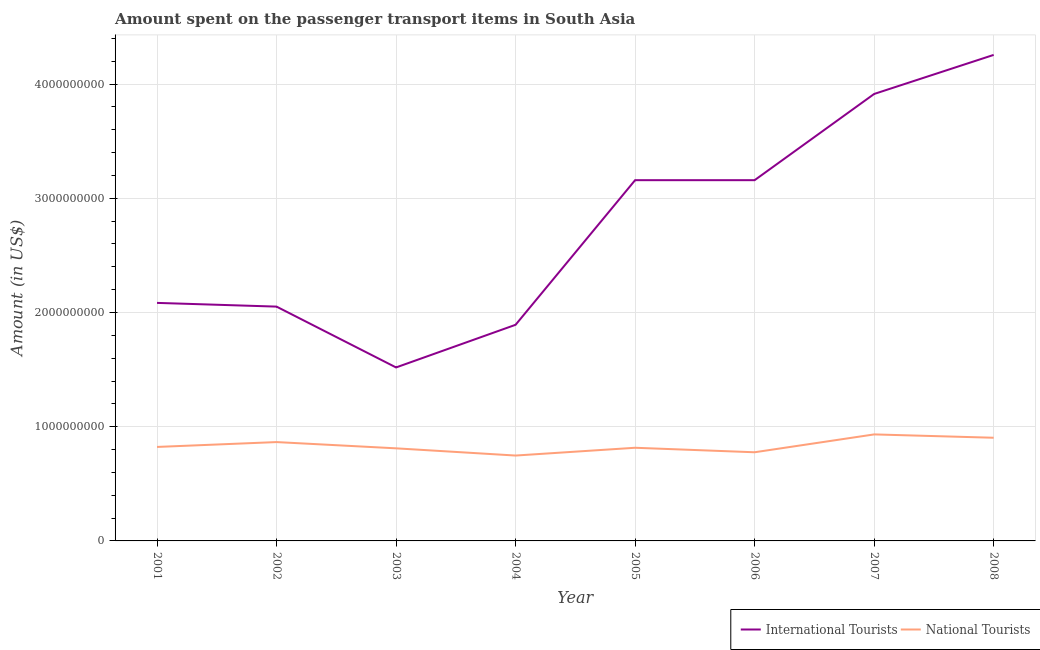Does the line corresponding to amount spent on transport items of international tourists intersect with the line corresponding to amount spent on transport items of national tourists?
Offer a terse response. No. What is the amount spent on transport items of national tourists in 2002?
Offer a very short reply. 8.66e+08. Across all years, what is the maximum amount spent on transport items of international tourists?
Make the answer very short. 4.26e+09. Across all years, what is the minimum amount spent on transport items of national tourists?
Your answer should be very brief. 7.48e+08. In which year was the amount spent on transport items of international tourists maximum?
Your answer should be very brief. 2008. What is the total amount spent on transport items of national tourists in the graph?
Your answer should be very brief. 6.68e+09. What is the difference between the amount spent on transport items of national tourists in 2004 and that in 2005?
Your answer should be compact. -6.81e+07. What is the difference between the amount spent on transport items of international tourists in 2004 and the amount spent on transport items of national tourists in 2002?
Ensure brevity in your answer.  1.03e+09. What is the average amount spent on transport items of international tourists per year?
Keep it short and to the point. 2.75e+09. In the year 2002, what is the difference between the amount spent on transport items of international tourists and amount spent on transport items of national tourists?
Offer a terse response. 1.19e+09. What is the ratio of the amount spent on transport items of international tourists in 2002 to that in 2005?
Your response must be concise. 0.65. Is the difference between the amount spent on transport items of national tourists in 2001 and 2008 greater than the difference between the amount spent on transport items of international tourists in 2001 and 2008?
Give a very brief answer. Yes. What is the difference between the highest and the second highest amount spent on transport items of national tourists?
Keep it short and to the point. 2.92e+07. What is the difference between the highest and the lowest amount spent on transport items of international tourists?
Keep it short and to the point. 2.74e+09. Is the sum of the amount spent on transport items of national tourists in 2002 and 2005 greater than the maximum amount spent on transport items of international tourists across all years?
Keep it short and to the point. No. Does the amount spent on transport items of international tourists monotonically increase over the years?
Offer a terse response. No. Is the amount spent on transport items of national tourists strictly less than the amount spent on transport items of international tourists over the years?
Provide a short and direct response. Yes. How many lines are there?
Offer a very short reply. 2. How many years are there in the graph?
Give a very brief answer. 8. Where does the legend appear in the graph?
Provide a succinct answer. Bottom right. What is the title of the graph?
Keep it short and to the point. Amount spent on the passenger transport items in South Asia. Does "Under-5(female)" appear as one of the legend labels in the graph?
Give a very brief answer. No. What is the label or title of the Y-axis?
Offer a terse response. Amount (in US$). What is the Amount (in US$) of International Tourists in 2001?
Provide a short and direct response. 2.08e+09. What is the Amount (in US$) in National Tourists in 2001?
Offer a very short reply. 8.23e+08. What is the Amount (in US$) in International Tourists in 2002?
Offer a terse response. 2.05e+09. What is the Amount (in US$) in National Tourists in 2002?
Give a very brief answer. 8.66e+08. What is the Amount (in US$) in International Tourists in 2003?
Provide a succinct answer. 1.52e+09. What is the Amount (in US$) in National Tourists in 2003?
Offer a terse response. 8.11e+08. What is the Amount (in US$) in International Tourists in 2004?
Ensure brevity in your answer.  1.89e+09. What is the Amount (in US$) in National Tourists in 2004?
Offer a very short reply. 7.48e+08. What is the Amount (in US$) in International Tourists in 2005?
Provide a short and direct response. 3.16e+09. What is the Amount (in US$) in National Tourists in 2005?
Offer a very short reply. 8.16e+08. What is the Amount (in US$) of International Tourists in 2006?
Provide a short and direct response. 3.16e+09. What is the Amount (in US$) of National Tourists in 2006?
Offer a very short reply. 7.76e+08. What is the Amount (in US$) of International Tourists in 2007?
Give a very brief answer. 3.91e+09. What is the Amount (in US$) of National Tourists in 2007?
Your answer should be very brief. 9.33e+08. What is the Amount (in US$) of International Tourists in 2008?
Offer a very short reply. 4.26e+09. What is the Amount (in US$) in National Tourists in 2008?
Keep it short and to the point. 9.03e+08. Across all years, what is the maximum Amount (in US$) in International Tourists?
Provide a succinct answer. 4.26e+09. Across all years, what is the maximum Amount (in US$) in National Tourists?
Your answer should be very brief. 9.33e+08. Across all years, what is the minimum Amount (in US$) of International Tourists?
Your response must be concise. 1.52e+09. Across all years, what is the minimum Amount (in US$) in National Tourists?
Provide a short and direct response. 7.48e+08. What is the total Amount (in US$) of International Tourists in the graph?
Give a very brief answer. 2.20e+1. What is the total Amount (in US$) of National Tourists in the graph?
Give a very brief answer. 6.68e+09. What is the difference between the Amount (in US$) in International Tourists in 2001 and that in 2002?
Your answer should be very brief. 3.25e+07. What is the difference between the Amount (in US$) of National Tourists in 2001 and that in 2002?
Your answer should be very brief. -4.25e+07. What is the difference between the Amount (in US$) in International Tourists in 2001 and that in 2003?
Offer a terse response. 5.65e+08. What is the difference between the Amount (in US$) of National Tourists in 2001 and that in 2003?
Provide a short and direct response. 1.22e+07. What is the difference between the Amount (in US$) in International Tourists in 2001 and that in 2004?
Offer a terse response. 1.92e+08. What is the difference between the Amount (in US$) of National Tourists in 2001 and that in 2004?
Offer a very short reply. 7.54e+07. What is the difference between the Amount (in US$) in International Tourists in 2001 and that in 2005?
Your answer should be very brief. -1.07e+09. What is the difference between the Amount (in US$) in National Tourists in 2001 and that in 2005?
Ensure brevity in your answer.  7.29e+06. What is the difference between the Amount (in US$) of International Tourists in 2001 and that in 2006?
Provide a short and direct response. -1.07e+09. What is the difference between the Amount (in US$) of National Tourists in 2001 and that in 2006?
Offer a terse response. 4.66e+07. What is the difference between the Amount (in US$) in International Tourists in 2001 and that in 2007?
Your response must be concise. -1.83e+09. What is the difference between the Amount (in US$) in National Tourists in 2001 and that in 2007?
Offer a terse response. -1.10e+08. What is the difference between the Amount (in US$) in International Tourists in 2001 and that in 2008?
Your answer should be compact. -2.17e+09. What is the difference between the Amount (in US$) in National Tourists in 2001 and that in 2008?
Make the answer very short. -8.05e+07. What is the difference between the Amount (in US$) of International Tourists in 2002 and that in 2003?
Make the answer very short. 5.33e+08. What is the difference between the Amount (in US$) in National Tourists in 2002 and that in 2003?
Give a very brief answer. 5.47e+07. What is the difference between the Amount (in US$) in International Tourists in 2002 and that in 2004?
Your answer should be compact. 1.59e+08. What is the difference between the Amount (in US$) in National Tourists in 2002 and that in 2004?
Offer a very short reply. 1.18e+08. What is the difference between the Amount (in US$) in International Tourists in 2002 and that in 2005?
Your answer should be compact. -1.11e+09. What is the difference between the Amount (in US$) of National Tourists in 2002 and that in 2005?
Give a very brief answer. 4.98e+07. What is the difference between the Amount (in US$) in International Tourists in 2002 and that in 2006?
Give a very brief answer. -1.11e+09. What is the difference between the Amount (in US$) of National Tourists in 2002 and that in 2006?
Provide a succinct answer. 8.92e+07. What is the difference between the Amount (in US$) in International Tourists in 2002 and that in 2007?
Offer a terse response. -1.86e+09. What is the difference between the Amount (in US$) of National Tourists in 2002 and that in 2007?
Offer a very short reply. -6.71e+07. What is the difference between the Amount (in US$) in International Tourists in 2002 and that in 2008?
Provide a succinct answer. -2.20e+09. What is the difference between the Amount (in US$) of National Tourists in 2002 and that in 2008?
Ensure brevity in your answer.  -3.79e+07. What is the difference between the Amount (in US$) in International Tourists in 2003 and that in 2004?
Offer a terse response. -3.73e+08. What is the difference between the Amount (in US$) of National Tourists in 2003 and that in 2004?
Provide a short and direct response. 6.32e+07. What is the difference between the Amount (in US$) in International Tourists in 2003 and that in 2005?
Provide a short and direct response. -1.64e+09. What is the difference between the Amount (in US$) of National Tourists in 2003 and that in 2005?
Offer a very short reply. -4.86e+06. What is the difference between the Amount (in US$) in International Tourists in 2003 and that in 2006?
Your answer should be very brief. -1.64e+09. What is the difference between the Amount (in US$) of National Tourists in 2003 and that in 2006?
Your response must be concise. 3.45e+07. What is the difference between the Amount (in US$) of International Tourists in 2003 and that in 2007?
Your answer should be very brief. -2.39e+09. What is the difference between the Amount (in US$) of National Tourists in 2003 and that in 2007?
Provide a succinct answer. -1.22e+08. What is the difference between the Amount (in US$) in International Tourists in 2003 and that in 2008?
Your response must be concise. -2.74e+09. What is the difference between the Amount (in US$) of National Tourists in 2003 and that in 2008?
Offer a very short reply. -9.26e+07. What is the difference between the Amount (in US$) of International Tourists in 2004 and that in 2005?
Your response must be concise. -1.27e+09. What is the difference between the Amount (in US$) of National Tourists in 2004 and that in 2005?
Keep it short and to the point. -6.81e+07. What is the difference between the Amount (in US$) of International Tourists in 2004 and that in 2006?
Ensure brevity in your answer.  -1.27e+09. What is the difference between the Amount (in US$) in National Tourists in 2004 and that in 2006?
Keep it short and to the point. -2.88e+07. What is the difference between the Amount (in US$) of International Tourists in 2004 and that in 2007?
Provide a short and direct response. -2.02e+09. What is the difference between the Amount (in US$) in National Tourists in 2004 and that in 2007?
Provide a short and direct response. -1.85e+08. What is the difference between the Amount (in US$) of International Tourists in 2004 and that in 2008?
Your answer should be compact. -2.36e+09. What is the difference between the Amount (in US$) of National Tourists in 2004 and that in 2008?
Keep it short and to the point. -1.56e+08. What is the difference between the Amount (in US$) in International Tourists in 2005 and that in 2006?
Your response must be concise. 0. What is the difference between the Amount (in US$) in National Tourists in 2005 and that in 2006?
Make the answer very short. 3.93e+07. What is the difference between the Amount (in US$) in International Tourists in 2005 and that in 2007?
Provide a short and direct response. -7.55e+08. What is the difference between the Amount (in US$) in National Tourists in 2005 and that in 2007?
Your answer should be very brief. -1.17e+08. What is the difference between the Amount (in US$) of International Tourists in 2005 and that in 2008?
Provide a succinct answer. -1.10e+09. What is the difference between the Amount (in US$) in National Tourists in 2005 and that in 2008?
Keep it short and to the point. -8.78e+07. What is the difference between the Amount (in US$) in International Tourists in 2006 and that in 2007?
Provide a succinct answer. -7.55e+08. What is the difference between the Amount (in US$) of National Tourists in 2006 and that in 2007?
Your response must be concise. -1.56e+08. What is the difference between the Amount (in US$) in International Tourists in 2006 and that in 2008?
Provide a short and direct response. -1.10e+09. What is the difference between the Amount (in US$) in National Tourists in 2006 and that in 2008?
Your response must be concise. -1.27e+08. What is the difference between the Amount (in US$) of International Tourists in 2007 and that in 2008?
Your answer should be very brief. -3.42e+08. What is the difference between the Amount (in US$) of National Tourists in 2007 and that in 2008?
Provide a short and direct response. 2.92e+07. What is the difference between the Amount (in US$) of International Tourists in 2001 and the Amount (in US$) of National Tourists in 2002?
Make the answer very short. 1.22e+09. What is the difference between the Amount (in US$) of International Tourists in 2001 and the Amount (in US$) of National Tourists in 2003?
Offer a very short reply. 1.27e+09. What is the difference between the Amount (in US$) in International Tourists in 2001 and the Amount (in US$) in National Tourists in 2004?
Your answer should be very brief. 1.34e+09. What is the difference between the Amount (in US$) in International Tourists in 2001 and the Amount (in US$) in National Tourists in 2005?
Give a very brief answer. 1.27e+09. What is the difference between the Amount (in US$) of International Tourists in 2001 and the Amount (in US$) of National Tourists in 2006?
Offer a terse response. 1.31e+09. What is the difference between the Amount (in US$) in International Tourists in 2001 and the Amount (in US$) in National Tourists in 2007?
Keep it short and to the point. 1.15e+09. What is the difference between the Amount (in US$) of International Tourists in 2001 and the Amount (in US$) of National Tourists in 2008?
Make the answer very short. 1.18e+09. What is the difference between the Amount (in US$) in International Tourists in 2002 and the Amount (in US$) in National Tourists in 2003?
Give a very brief answer. 1.24e+09. What is the difference between the Amount (in US$) of International Tourists in 2002 and the Amount (in US$) of National Tourists in 2004?
Make the answer very short. 1.30e+09. What is the difference between the Amount (in US$) of International Tourists in 2002 and the Amount (in US$) of National Tourists in 2005?
Give a very brief answer. 1.24e+09. What is the difference between the Amount (in US$) of International Tourists in 2002 and the Amount (in US$) of National Tourists in 2006?
Make the answer very short. 1.28e+09. What is the difference between the Amount (in US$) of International Tourists in 2002 and the Amount (in US$) of National Tourists in 2007?
Keep it short and to the point. 1.12e+09. What is the difference between the Amount (in US$) of International Tourists in 2002 and the Amount (in US$) of National Tourists in 2008?
Give a very brief answer. 1.15e+09. What is the difference between the Amount (in US$) of International Tourists in 2003 and the Amount (in US$) of National Tourists in 2004?
Your answer should be compact. 7.71e+08. What is the difference between the Amount (in US$) in International Tourists in 2003 and the Amount (in US$) in National Tourists in 2005?
Provide a short and direct response. 7.03e+08. What is the difference between the Amount (in US$) of International Tourists in 2003 and the Amount (in US$) of National Tourists in 2006?
Provide a succinct answer. 7.43e+08. What is the difference between the Amount (in US$) of International Tourists in 2003 and the Amount (in US$) of National Tourists in 2007?
Give a very brief answer. 5.86e+08. What is the difference between the Amount (in US$) of International Tourists in 2003 and the Amount (in US$) of National Tourists in 2008?
Make the answer very short. 6.16e+08. What is the difference between the Amount (in US$) of International Tourists in 2004 and the Amount (in US$) of National Tourists in 2005?
Your answer should be very brief. 1.08e+09. What is the difference between the Amount (in US$) in International Tourists in 2004 and the Amount (in US$) in National Tourists in 2006?
Give a very brief answer. 1.12e+09. What is the difference between the Amount (in US$) of International Tourists in 2004 and the Amount (in US$) of National Tourists in 2007?
Offer a very short reply. 9.60e+08. What is the difference between the Amount (in US$) of International Tourists in 2004 and the Amount (in US$) of National Tourists in 2008?
Offer a terse response. 9.89e+08. What is the difference between the Amount (in US$) of International Tourists in 2005 and the Amount (in US$) of National Tourists in 2006?
Your answer should be very brief. 2.38e+09. What is the difference between the Amount (in US$) of International Tourists in 2005 and the Amount (in US$) of National Tourists in 2007?
Your answer should be compact. 2.23e+09. What is the difference between the Amount (in US$) of International Tourists in 2005 and the Amount (in US$) of National Tourists in 2008?
Your answer should be very brief. 2.26e+09. What is the difference between the Amount (in US$) in International Tourists in 2006 and the Amount (in US$) in National Tourists in 2007?
Offer a terse response. 2.23e+09. What is the difference between the Amount (in US$) in International Tourists in 2006 and the Amount (in US$) in National Tourists in 2008?
Offer a terse response. 2.26e+09. What is the difference between the Amount (in US$) of International Tourists in 2007 and the Amount (in US$) of National Tourists in 2008?
Offer a very short reply. 3.01e+09. What is the average Amount (in US$) of International Tourists per year?
Provide a succinct answer. 2.75e+09. What is the average Amount (in US$) of National Tourists per year?
Offer a terse response. 8.34e+08. In the year 2001, what is the difference between the Amount (in US$) of International Tourists and Amount (in US$) of National Tourists?
Keep it short and to the point. 1.26e+09. In the year 2002, what is the difference between the Amount (in US$) in International Tourists and Amount (in US$) in National Tourists?
Your answer should be compact. 1.19e+09. In the year 2003, what is the difference between the Amount (in US$) of International Tourists and Amount (in US$) of National Tourists?
Make the answer very short. 7.08e+08. In the year 2004, what is the difference between the Amount (in US$) of International Tourists and Amount (in US$) of National Tourists?
Provide a succinct answer. 1.14e+09. In the year 2005, what is the difference between the Amount (in US$) in International Tourists and Amount (in US$) in National Tourists?
Ensure brevity in your answer.  2.34e+09. In the year 2006, what is the difference between the Amount (in US$) in International Tourists and Amount (in US$) in National Tourists?
Your response must be concise. 2.38e+09. In the year 2007, what is the difference between the Amount (in US$) of International Tourists and Amount (in US$) of National Tourists?
Your answer should be very brief. 2.98e+09. In the year 2008, what is the difference between the Amount (in US$) of International Tourists and Amount (in US$) of National Tourists?
Offer a terse response. 3.35e+09. What is the ratio of the Amount (in US$) of International Tourists in 2001 to that in 2002?
Offer a terse response. 1.02. What is the ratio of the Amount (in US$) of National Tourists in 2001 to that in 2002?
Your answer should be compact. 0.95. What is the ratio of the Amount (in US$) of International Tourists in 2001 to that in 2003?
Ensure brevity in your answer.  1.37. What is the ratio of the Amount (in US$) in National Tourists in 2001 to that in 2003?
Offer a terse response. 1.01. What is the ratio of the Amount (in US$) in International Tourists in 2001 to that in 2004?
Make the answer very short. 1.1. What is the ratio of the Amount (in US$) in National Tourists in 2001 to that in 2004?
Offer a terse response. 1.1. What is the ratio of the Amount (in US$) in International Tourists in 2001 to that in 2005?
Keep it short and to the point. 0.66. What is the ratio of the Amount (in US$) in National Tourists in 2001 to that in 2005?
Ensure brevity in your answer.  1.01. What is the ratio of the Amount (in US$) of International Tourists in 2001 to that in 2006?
Provide a succinct answer. 0.66. What is the ratio of the Amount (in US$) of National Tourists in 2001 to that in 2006?
Ensure brevity in your answer.  1.06. What is the ratio of the Amount (in US$) of International Tourists in 2001 to that in 2007?
Provide a short and direct response. 0.53. What is the ratio of the Amount (in US$) of National Tourists in 2001 to that in 2007?
Your answer should be very brief. 0.88. What is the ratio of the Amount (in US$) of International Tourists in 2001 to that in 2008?
Provide a short and direct response. 0.49. What is the ratio of the Amount (in US$) of National Tourists in 2001 to that in 2008?
Provide a succinct answer. 0.91. What is the ratio of the Amount (in US$) of International Tourists in 2002 to that in 2003?
Your answer should be very brief. 1.35. What is the ratio of the Amount (in US$) in National Tourists in 2002 to that in 2003?
Your answer should be very brief. 1.07. What is the ratio of the Amount (in US$) in International Tourists in 2002 to that in 2004?
Your answer should be compact. 1.08. What is the ratio of the Amount (in US$) of National Tourists in 2002 to that in 2004?
Offer a very short reply. 1.16. What is the ratio of the Amount (in US$) of International Tourists in 2002 to that in 2005?
Provide a short and direct response. 0.65. What is the ratio of the Amount (in US$) of National Tourists in 2002 to that in 2005?
Provide a short and direct response. 1.06. What is the ratio of the Amount (in US$) in International Tourists in 2002 to that in 2006?
Offer a terse response. 0.65. What is the ratio of the Amount (in US$) of National Tourists in 2002 to that in 2006?
Provide a succinct answer. 1.11. What is the ratio of the Amount (in US$) of International Tourists in 2002 to that in 2007?
Your response must be concise. 0.52. What is the ratio of the Amount (in US$) of National Tourists in 2002 to that in 2007?
Your answer should be very brief. 0.93. What is the ratio of the Amount (in US$) in International Tourists in 2002 to that in 2008?
Provide a succinct answer. 0.48. What is the ratio of the Amount (in US$) of National Tourists in 2002 to that in 2008?
Provide a short and direct response. 0.96. What is the ratio of the Amount (in US$) of International Tourists in 2003 to that in 2004?
Offer a terse response. 0.8. What is the ratio of the Amount (in US$) of National Tourists in 2003 to that in 2004?
Your answer should be compact. 1.08. What is the ratio of the Amount (in US$) in International Tourists in 2003 to that in 2005?
Keep it short and to the point. 0.48. What is the ratio of the Amount (in US$) in National Tourists in 2003 to that in 2005?
Your answer should be very brief. 0.99. What is the ratio of the Amount (in US$) of International Tourists in 2003 to that in 2006?
Provide a short and direct response. 0.48. What is the ratio of the Amount (in US$) of National Tourists in 2003 to that in 2006?
Make the answer very short. 1.04. What is the ratio of the Amount (in US$) in International Tourists in 2003 to that in 2007?
Offer a very short reply. 0.39. What is the ratio of the Amount (in US$) of National Tourists in 2003 to that in 2007?
Give a very brief answer. 0.87. What is the ratio of the Amount (in US$) in International Tourists in 2003 to that in 2008?
Your response must be concise. 0.36. What is the ratio of the Amount (in US$) in National Tourists in 2003 to that in 2008?
Offer a terse response. 0.9. What is the ratio of the Amount (in US$) of International Tourists in 2004 to that in 2005?
Offer a terse response. 0.6. What is the ratio of the Amount (in US$) of National Tourists in 2004 to that in 2005?
Your answer should be very brief. 0.92. What is the ratio of the Amount (in US$) in International Tourists in 2004 to that in 2006?
Keep it short and to the point. 0.6. What is the ratio of the Amount (in US$) of National Tourists in 2004 to that in 2006?
Your answer should be compact. 0.96. What is the ratio of the Amount (in US$) of International Tourists in 2004 to that in 2007?
Your answer should be compact. 0.48. What is the ratio of the Amount (in US$) of National Tourists in 2004 to that in 2007?
Offer a terse response. 0.8. What is the ratio of the Amount (in US$) of International Tourists in 2004 to that in 2008?
Your answer should be very brief. 0.44. What is the ratio of the Amount (in US$) in National Tourists in 2004 to that in 2008?
Provide a succinct answer. 0.83. What is the ratio of the Amount (in US$) of National Tourists in 2005 to that in 2006?
Offer a very short reply. 1.05. What is the ratio of the Amount (in US$) in International Tourists in 2005 to that in 2007?
Offer a terse response. 0.81. What is the ratio of the Amount (in US$) of National Tourists in 2005 to that in 2007?
Offer a terse response. 0.87. What is the ratio of the Amount (in US$) of International Tourists in 2005 to that in 2008?
Your response must be concise. 0.74. What is the ratio of the Amount (in US$) of National Tourists in 2005 to that in 2008?
Provide a short and direct response. 0.9. What is the ratio of the Amount (in US$) of International Tourists in 2006 to that in 2007?
Provide a short and direct response. 0.81. What is the ratio of the Amount (in US$) of National Tourists in 2006 to that in 2007?
Offer a very short reply. 0.83. What is the ratio of the Amount (in US$) of International Tourists in 2006 to that in 2008?
Ensure brevity in your answer.  0.74. What is the ratio of the Amount (in US$) of National Tourists in 2006 to that in 2008?
Your answer should be very brief. 0.86. What is the ratio of the Amount (in US$) of International Tourists in 2007 to that in 2008?
Keep it short and to the point. 0.92. What is the ratio of the Amount (in US$) of National Tourists in 2007 to that in 2008?
Make the answer very short. 1.03. What is the difference between the highest and the second highest Amount (in US$) of International Tourists?
Offer a very short reply. 3.42e+08. What is the difference between the highest and the second highest Amount (in US$) in National Tourists?
Provide a succinct answer. 2.92e+07. What is the difference between the highest and the lowest Amount (in US$) in International Tourists?
Keep it short and to the point. 2.74e+09. What is the difference between the highest and the lowest Amount (in US$) in National Tourists?
Provide a short and direct response. 1.85e+08. 